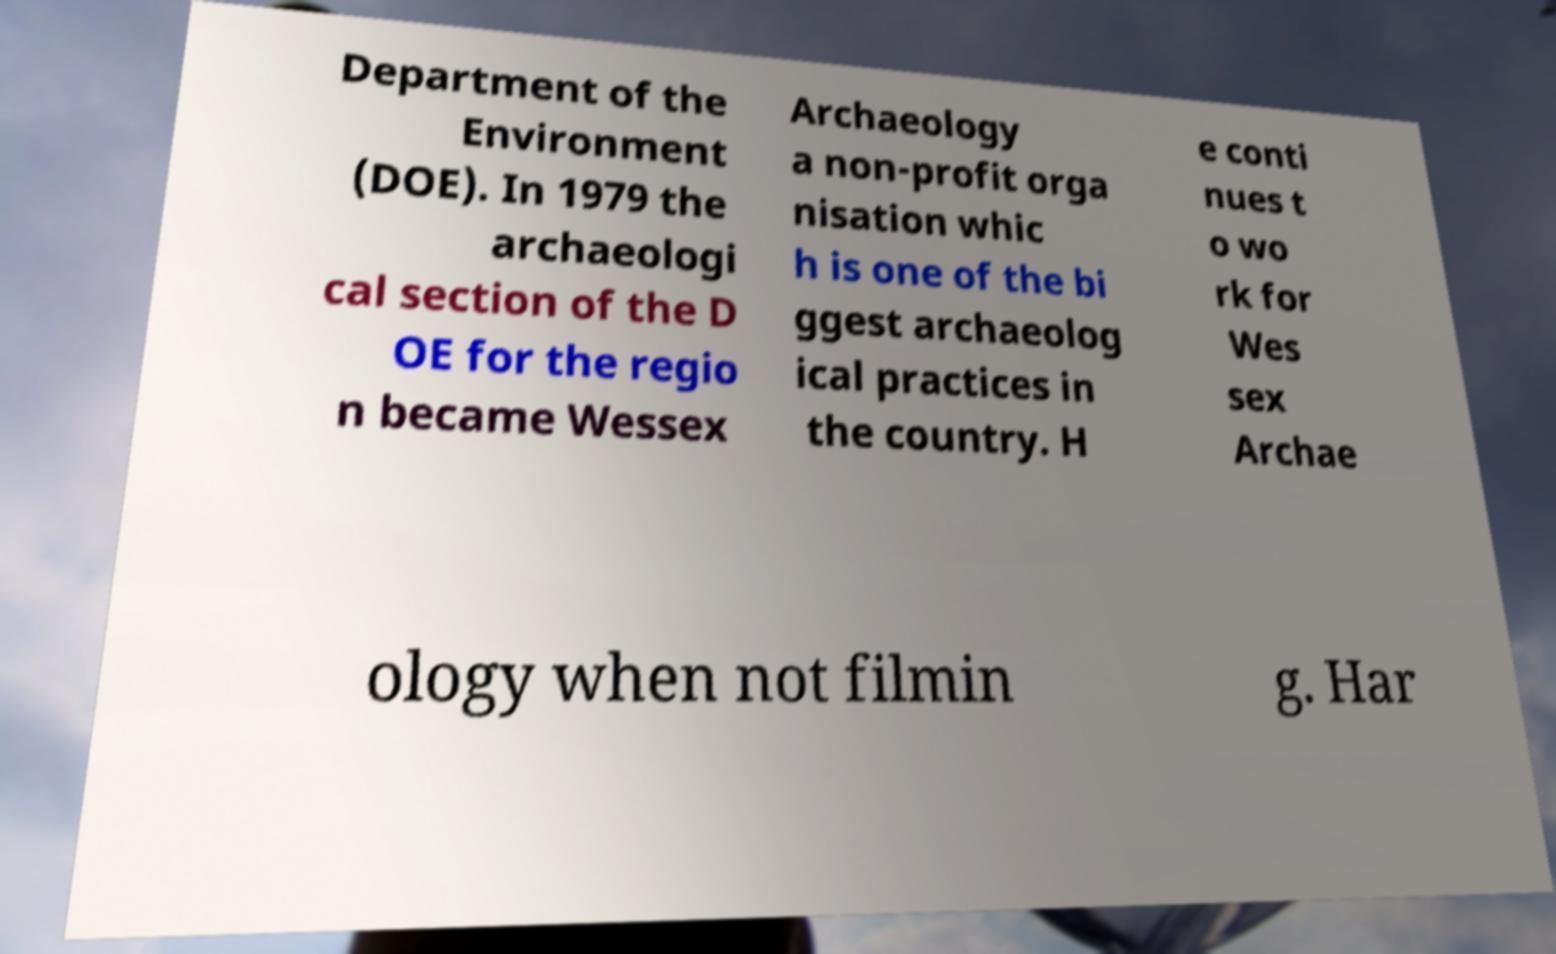Could you assist in decoding the text presented in this image and type it out clearly? Department of the Environment (DOE). In 1979 the archaeologi cal section of the D OE for the regio n became Wessex Archaeology a non-profit orga nisation whic h is one of the bi ggest archaeolog ical practices in the country. H e conti nues t o wo rk for Wes sex Archae ology when not filmin g. Har 